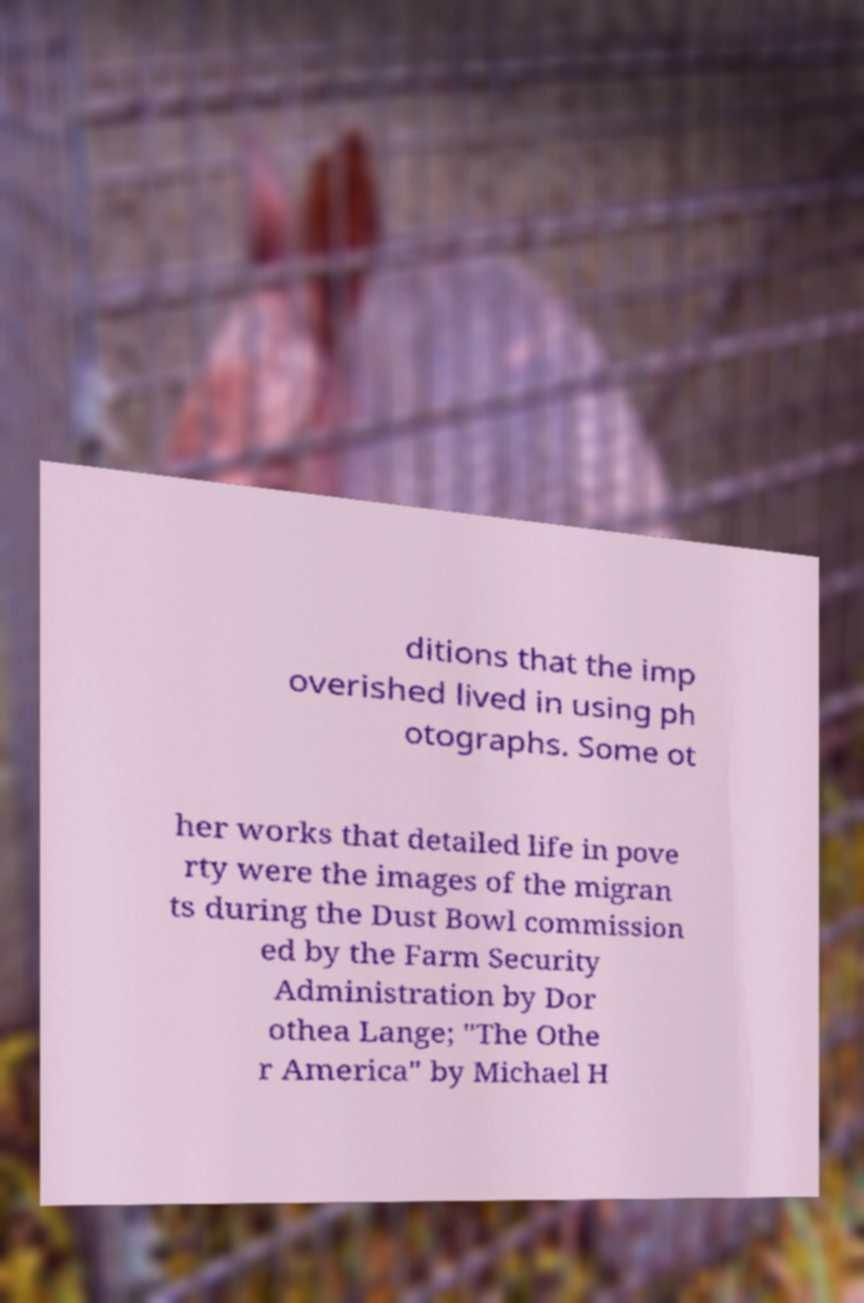What messages or text are displayed in this image? I need them in a readable, typed format. ditions that the imp overished lived in using ph otographs. Some ot her works that detailed life in pove rty were the images of the migran ts during the Dust Bowl commission ed by the Farm Security Administration by Dor othea Lange; "The Othe r America" by Michael H 